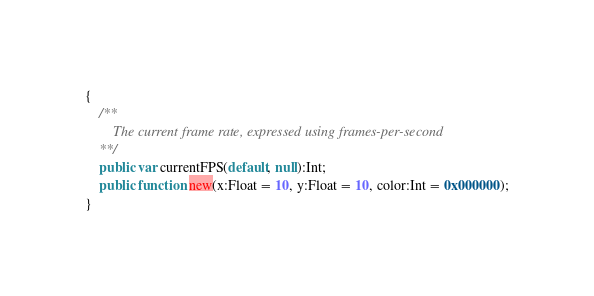Convert code to text. <code><loc_0><loc_0><loc_500><loc_500><_Haxe_>{
	/**
		The current frame rate, expressed using frames-per-second
	**/
	public var currentFPS(default, null):Int;
	public function new(x:Float = 10, y:Float = 10, color:Int = 0x000000);
}
</code> 